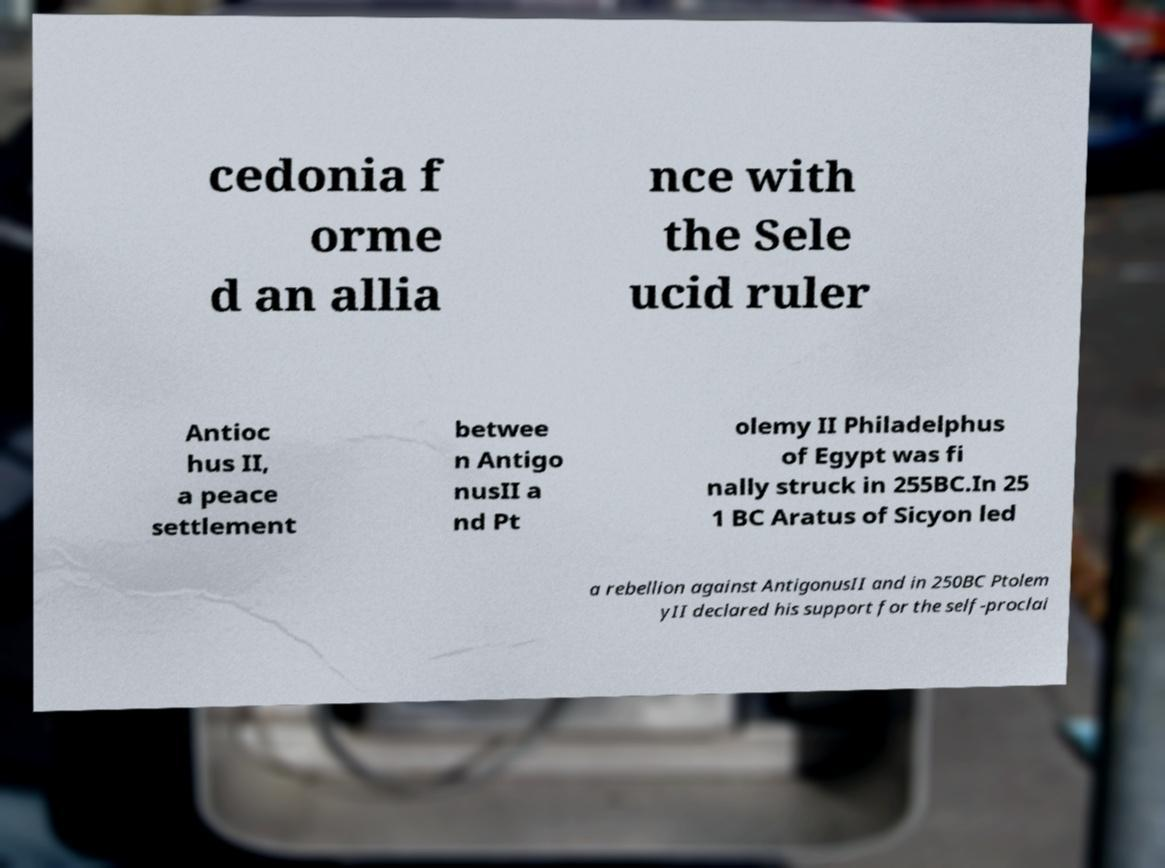Please read and relay the text visible in this image. What does it say? cedonia f orme d an allia nce with the Sele ucid ruler Antioc hus II, a peace settlement betwee n Antigo nusII a nd Pt olemy II Philadelphus of Egypt was fi nally struck in 255BC.In 25 1 BC Aratus of Sicyon led a rebellion against AntigonusII and in 250BC Ptolem yII declared his support for the self-proclai 